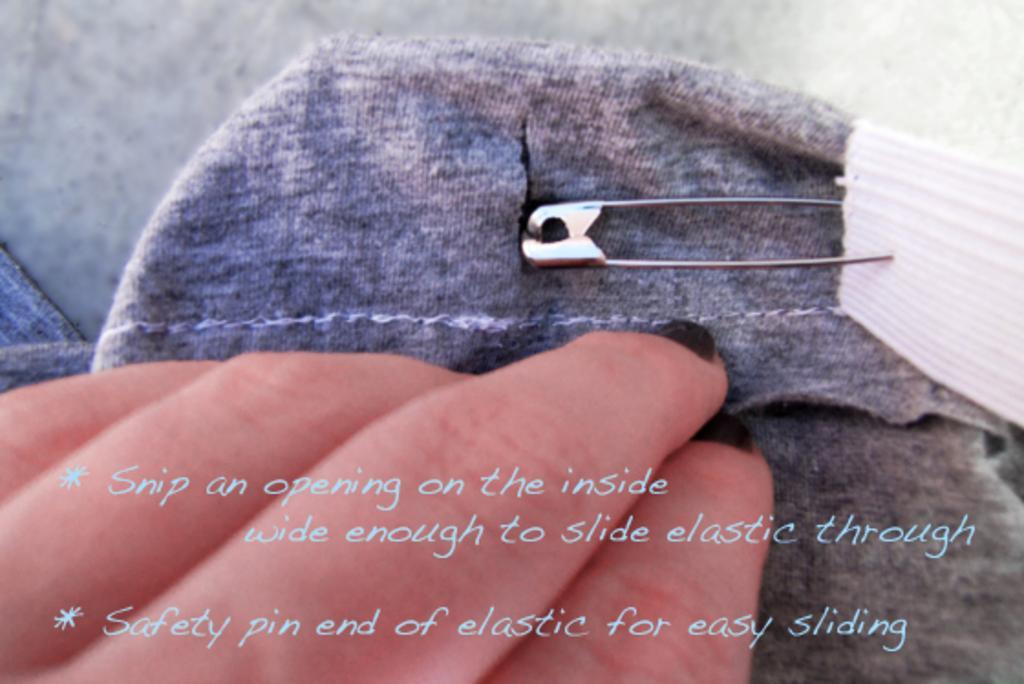Could you give a brief overview of what you see in this image? In this image there is a person's hand towards the bottom of the image, there is text towards the bottom of the image, there is a cloth towards the bottom of the image, there is an object towards the right of the image, there is a safety pin, there is ground towards the top of the image. 